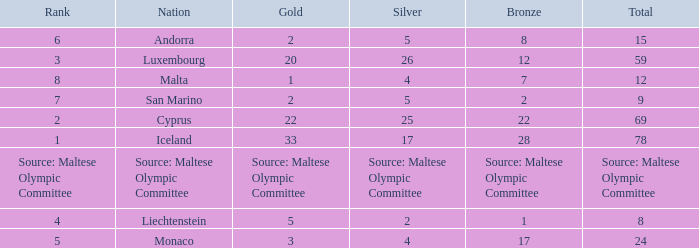What rank is the nation with 2 silver medals? 4.0. 